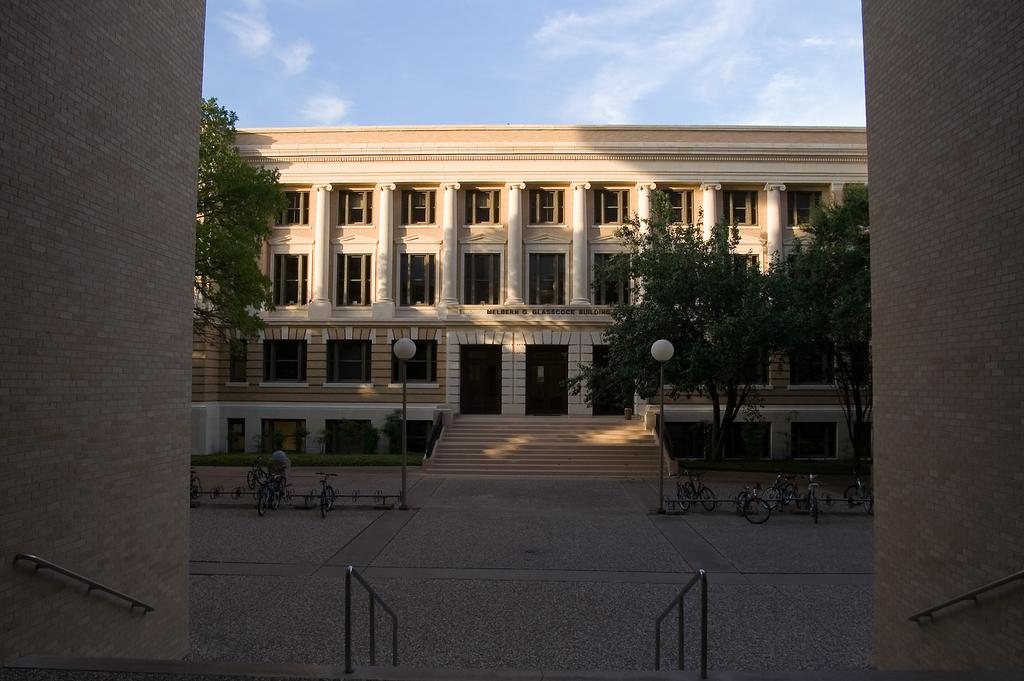What is the main structure in the image? There is a big building in the image. What type of natural elements can be seen in the image? There are trees in the image. What type of infrastructure is present in the image? Street light poles are visible in the image. What mode of transportation is parked on the road in the image? Bicycles are parked on the road in the image. Is there steam coming out of the building in the image? No, there is no steam coming out of the building in the image. 